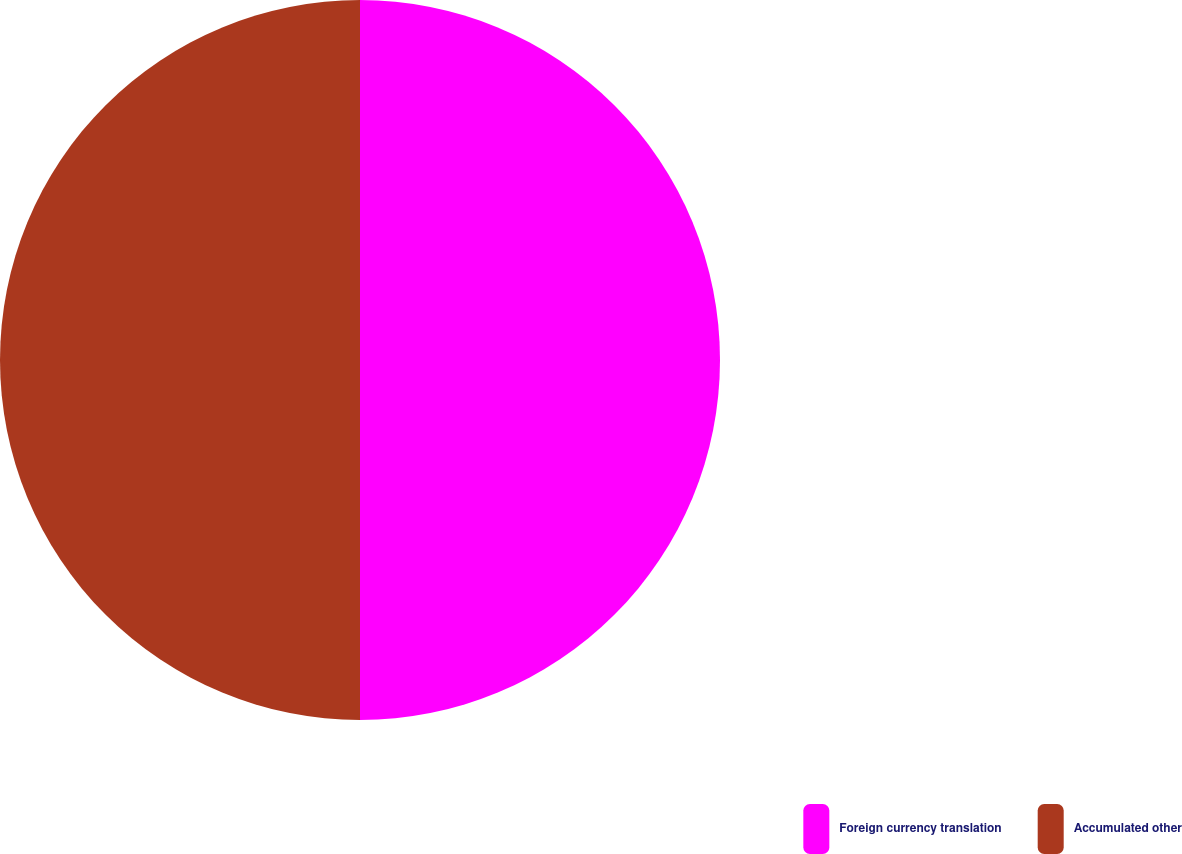Convert chart. <chart><loc_0><loc_0><loc_500><loc_500><pie_chart><fcel>Foreign currency translation<fcel>Accumulated other<nl><fcel>50.0%<fcel>50.0%<nl></chart> 